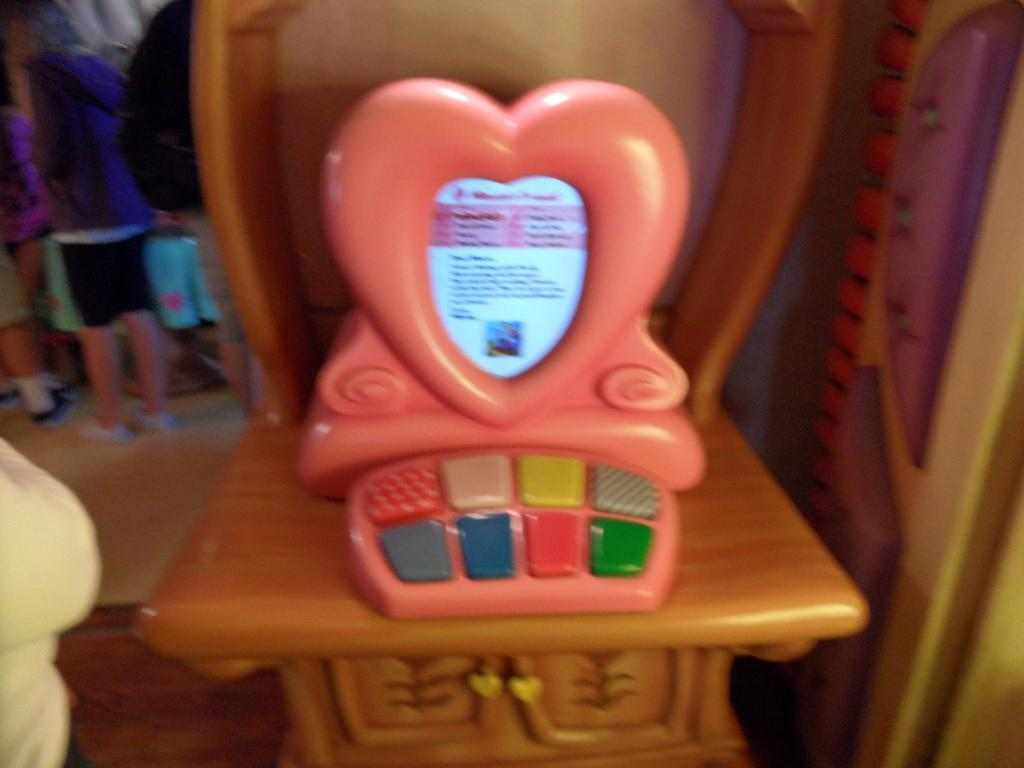What is the main subject in the center of the image? There is a toy on a stand in the center of the image. What can be seen in the background of the image? There are people and other objects visible in the background of the image. What part of the image shows the ground? The floor is visible at the bottom of the image. What type of verse can be heard being recited by the toy in the image? There is no indication in the image that the toy is reciting any verse, and therefore no such activity can be observed. 